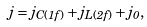<formula> <loc_0><loc_0><loc_500><loc_500>j = j _ { C ( 1 f ) } + j _ { L ( 2 f ) } + j _ { 0 } ,</formula> 